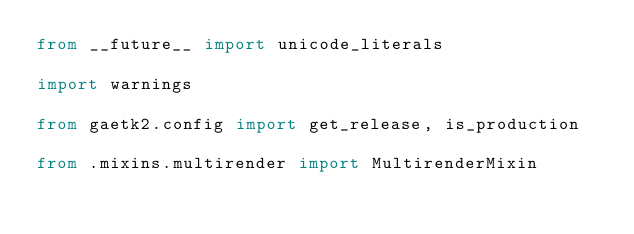<code> <loc_0><loc_0><loc_500><loc_500><_Python_>from __future__ import unicode_literals

import warnings

from gaetk2.config import get_release, is_production

from .mixins.multirender import MultirenderMixin</code> 